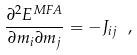<formula> <loc_0><loc_0><loc_500><loc_500>\frac { \partial ^ { 2 } E ^ { M F A } } { \partial m _ { i } \partial m _ { j } } = - J _ { i j } \ ,</formula> 